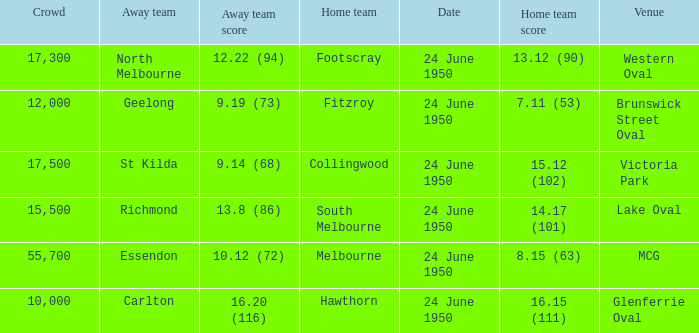In the game where north melbourne was the guest team, who was the host team? Footscray. 